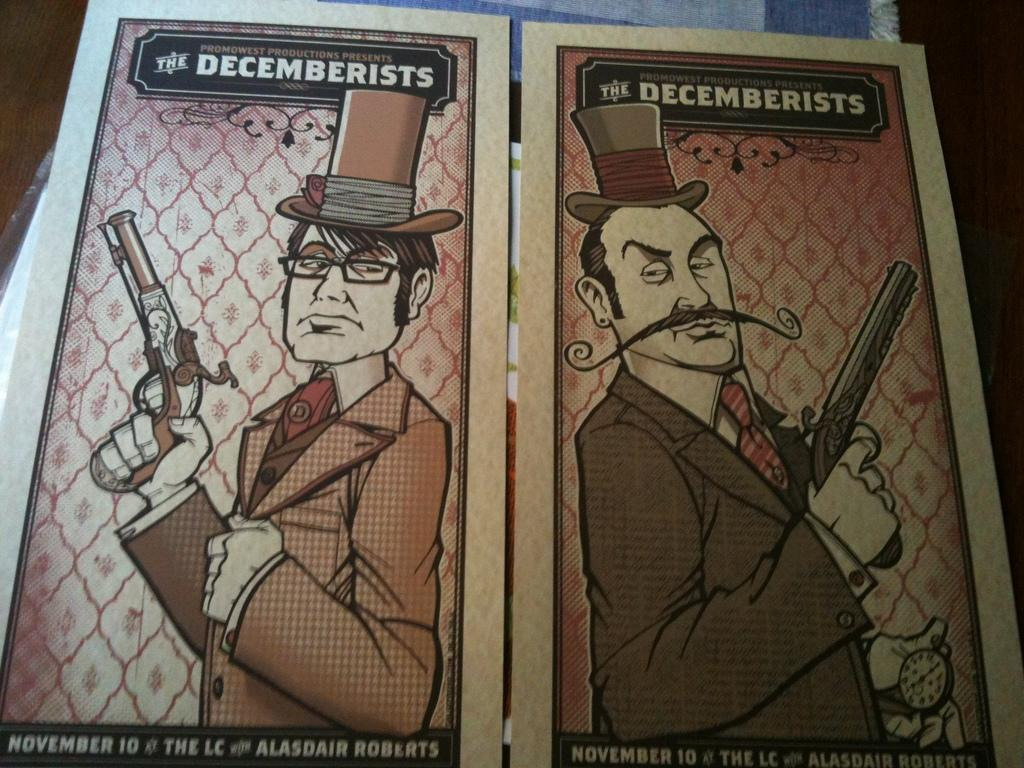What type of images are present on the posters in the image? There are posters of persons in the image. What are the persons on the posters holding? The persons on the posters are holding guns. What type of headwear are the persons on the posters wearing? The persons on the posters are wearing hats. What type of store can be seen in the background of the image? There is no store present in the image; it only features posters of persons holding guns and wearing hats. 